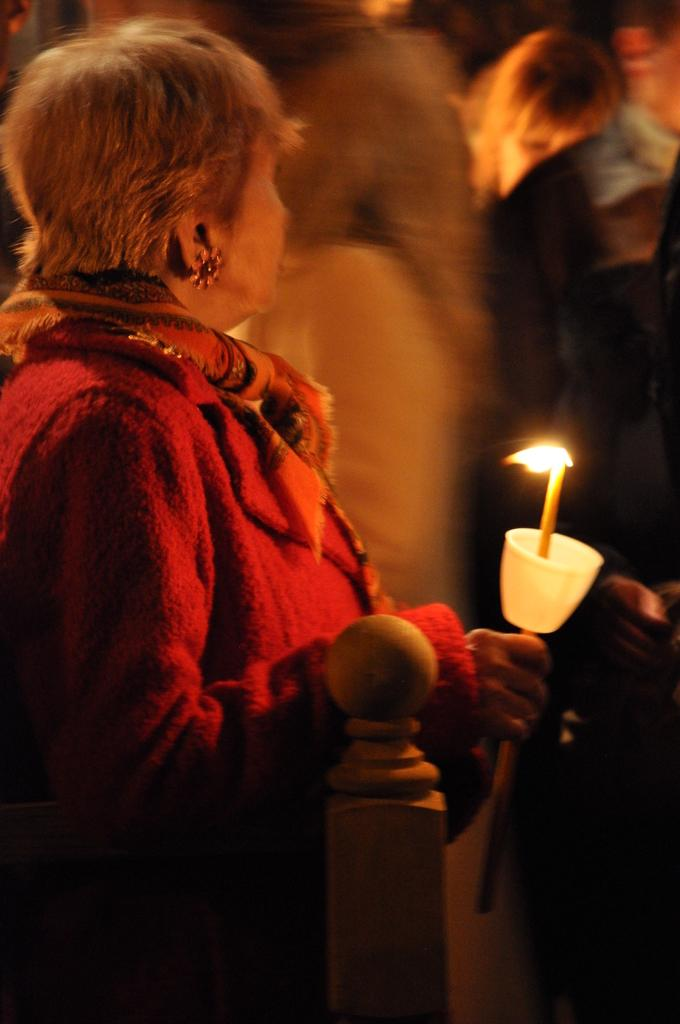Who is the main subject in the image? There is a woman in the image. What is the woman doing in the image? The woman is standing in the image. What object is the woman holding? The woman is holding a candle. Can you describe the background of the image? There are people in the background of the image. What type of star can be seen in the image? There is no star visible in the image. Is there a man present in the image? The main subject in the image is a woman, and there is no mention of a man. 